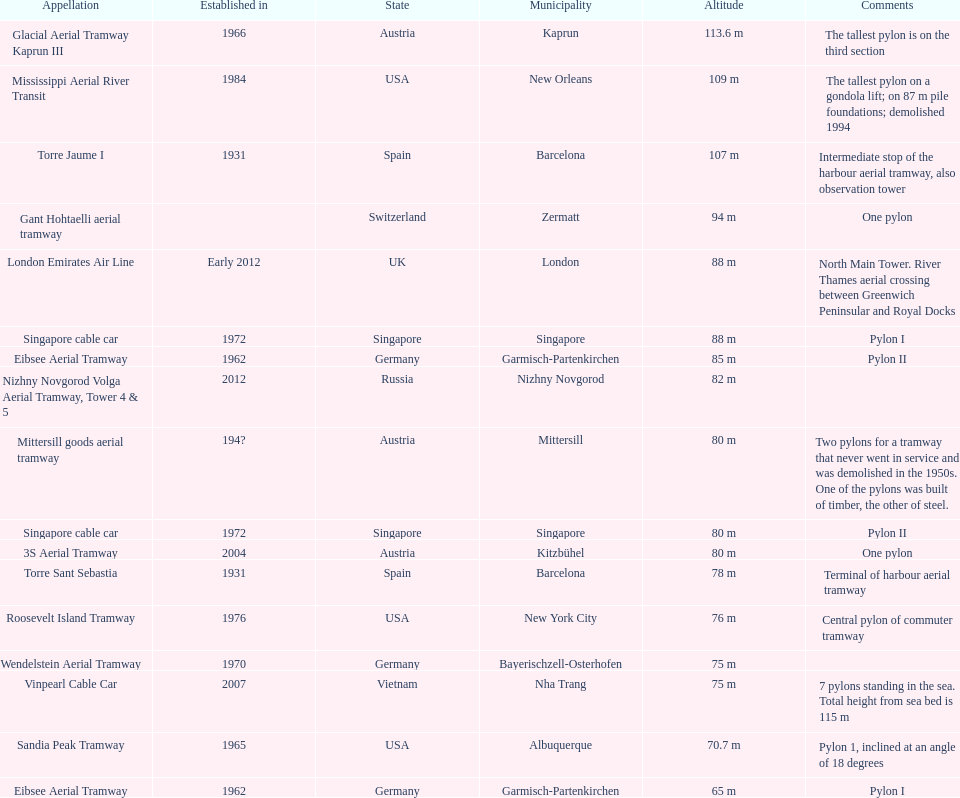What is the total number of pylons listed? 17. 